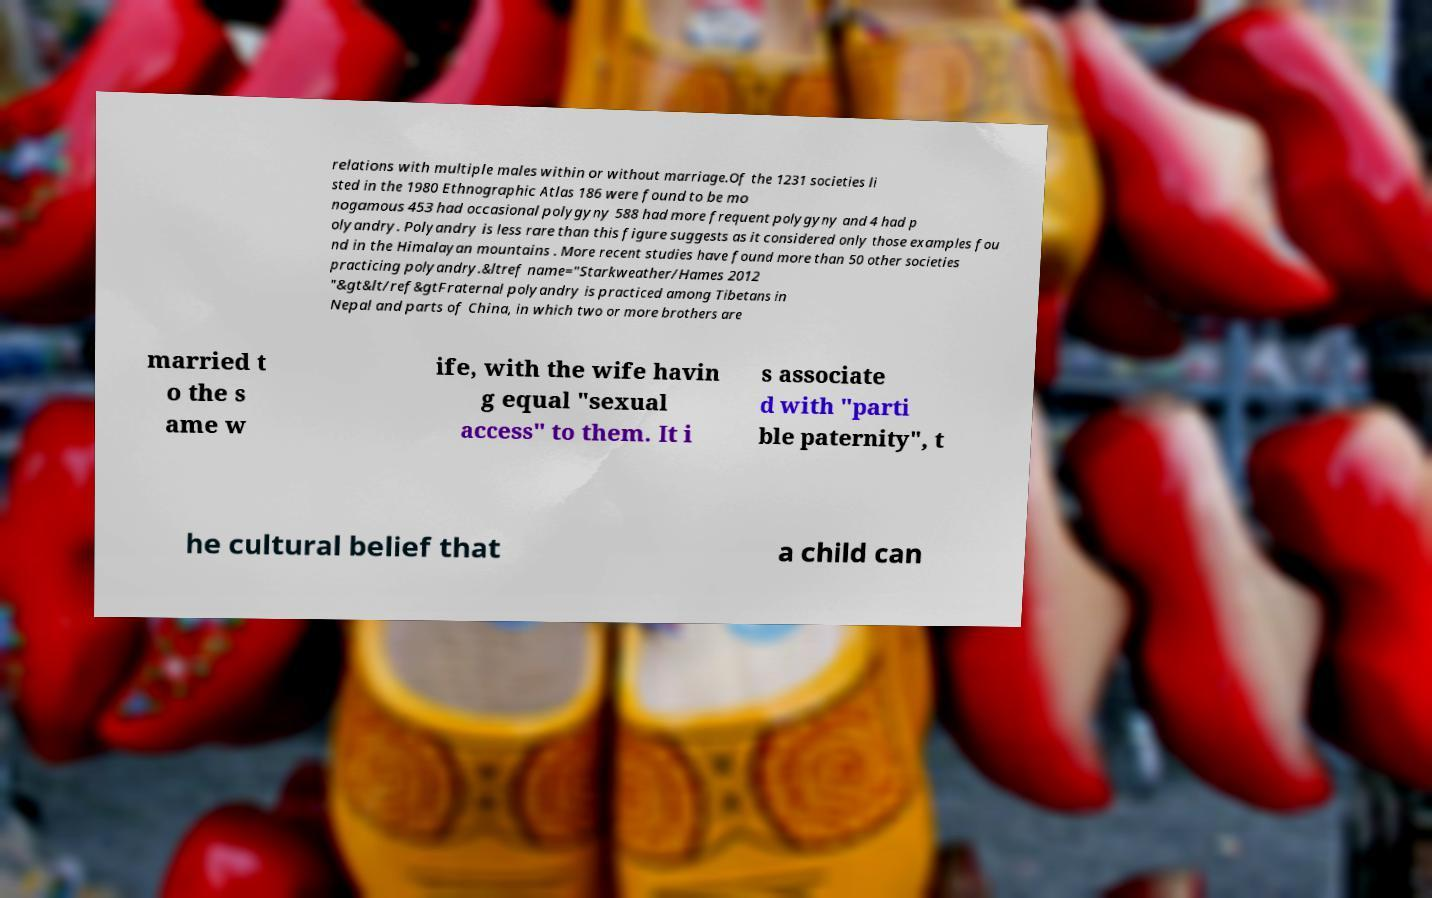Could you assist in decoding the text presented in this image and type it out clearly? relations with multiple males within or without marriage.Of the 1231 societies li sted in the 1980 Ethnographic Atlas 186 were found to be mo nogamous 453 had occasional polygyny 588 had more frequent polygyny and 4 had p olyandry. Polyandry is less rare than this figure suggests as it considered only those examples fou nd in the Himalayan mountains . More recent studies have found more than 50 other societies practicing polyandry.&ltref name="Starkweather/Hames 2012 "&gt&lt/ref&gtFraternal polyandry is practiced among Tibetans in Nepal and parts of China, in which two or more brothers are married t o the s ame w ife, with the wife havin g equal "sexual access" to them. It i s associate d with "parti ble paternity", t he cultural belief that a child can 